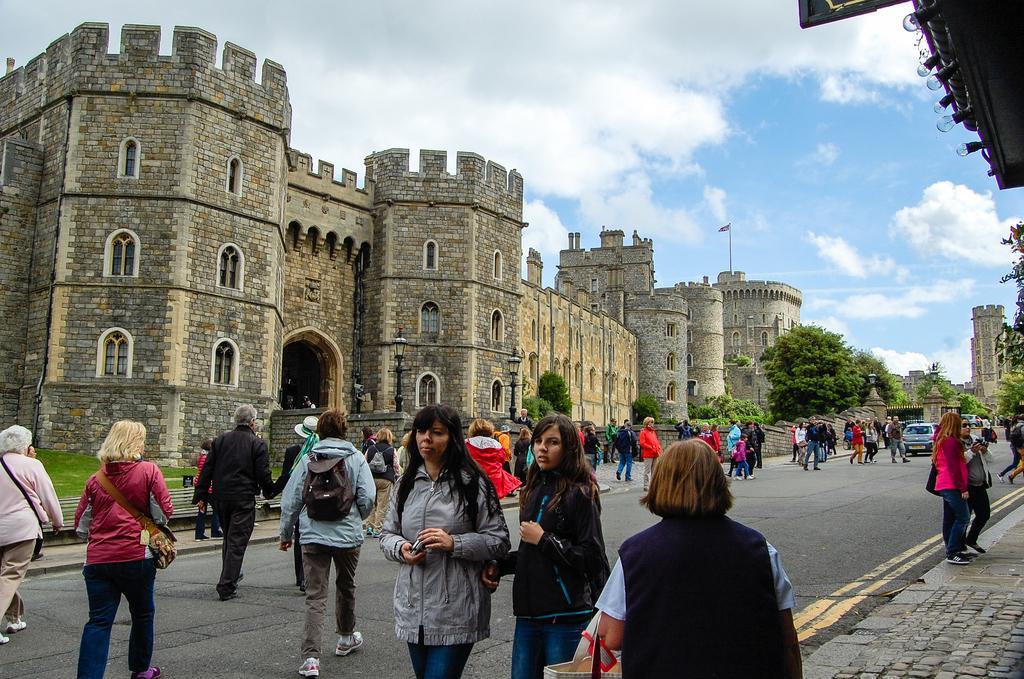Please provide a concise description of this image. In this picture there are people at the bottom side of the image and there is a building in the center of the image, there are cars and trees on the right side of the image. 